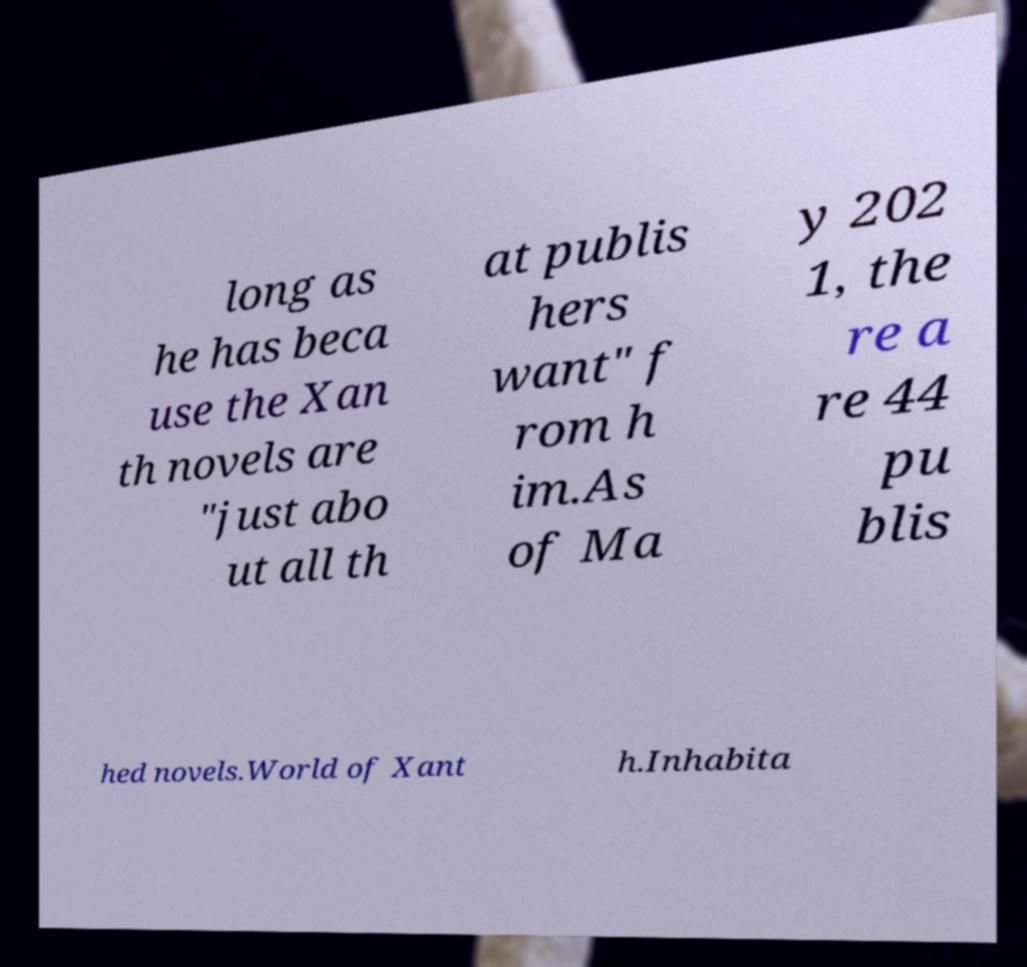What messages or text are displayed in this image? I need them in a readable, typed format. long as he has beca use the Xan th novels are "just abo ut all th at publis hers want" f rom h im.As of Ma y 202 1, the re a re 44 pu blis hed novels.World of Xant h.Inhabita 